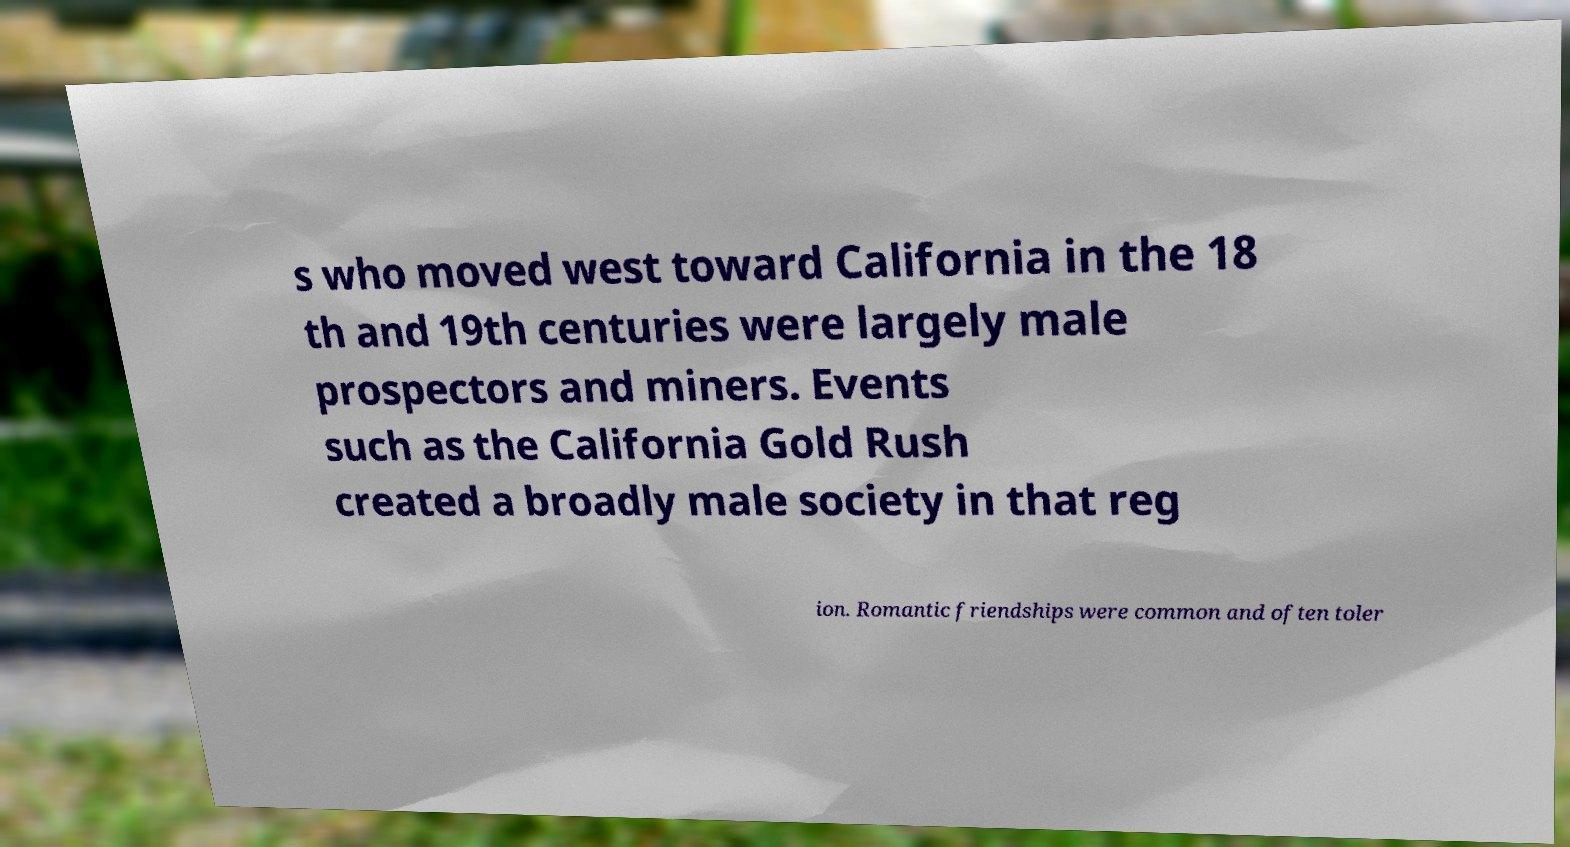What messages or text are displayed in this image? I need them in a readable, typed format. s who moved west toward California in the 18 th and 19th centuries were largely male prospectors and miners. Events such as the California Gold Rush created a broadly male society in that reg ion. Romantic friendships were common and often toler 